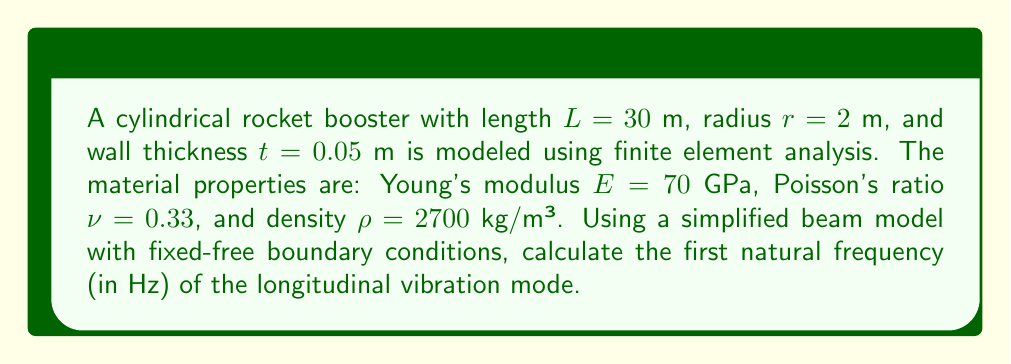What is the answer to this math problem? To solve this problem, we'll follow these steps:

1) For a fixed-free beam, the longitudinal vibration frequency is given by:

   $$f_n = \frac{n}{4L}\sqrt{\frac{E}{\rho}}$$

   where $n$ is the mode number (1 for the first mode).

2) We have all the necessary values except for the length $L$, which is given as 30 m.

3) Substituting the values:

   $$f_1 = \frac{1}{4(30)}\sqrt{\frac{70 \times 10^9}{2700}}$$

4) Simplify under the square root:

   $$f_1 = \frac{1}{120}\sqrt{\frac{70 \times 10^9}{2700}} = \frac{1}{120}\sqrt{25.93 \times 10^6}$$

5) Calculate the square root:

   $$f_1 = \frac{1}{120} \times 5091.17 = 42.43$$

6) Round to two decimal places:

   $$f_1 \approx 42.43 \text{ Hz}$$

Note: This simplified model assumes the rocket booster behaves like a slender beam. In practice, a more detailed finite element model would be used to capture the complex geometry and boundary conditions of the actual rocket structure.
Answer: 42.43 Hz 